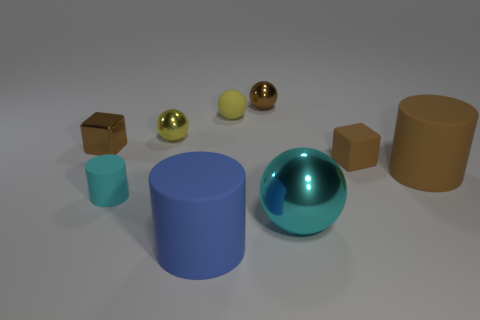What number of other things are there of the same color as the rubber ball?
Offer a terse response. 1. There is a cylinder that is right of the tiny brown rubber cube; is it the same size as the brown matte thing behind the brown rubber cylinder?
Make the answer very short. No. Is the number of metal blocks on the right side of the big blue thing the same as the number of shiny things on the right side of the small rubber block?
Offer a terse response. Yes. Is there anything else that has the same material as the brown cylinder?
Your answer should be very brief. Yes. There is a yellow rubber ball; is it the same size as the block that is left of the big ball?
Provide a succinct answer. Yes. What is the material of the tiny brown object that is behind the small brown thing left of the large blue matte cylinder?
Make the answer very short. Metal. Are there the same number of small matte objects in front of the brown shiny ball and small cyan matte balls?
Provide a short and direct response. No. How big is the ball that is both on the left side of the brown ball and in front of the yellow matte ball?
Give a very brief answer. Small. There is a small metal object to the left of the cyan thing that is on the left side of the yellow rubber ball; what is its color?
Provide a short and direct response. Brown. How many cyan objects are tiny spheres or tiny things?
Provide a short and direct response. 1. 